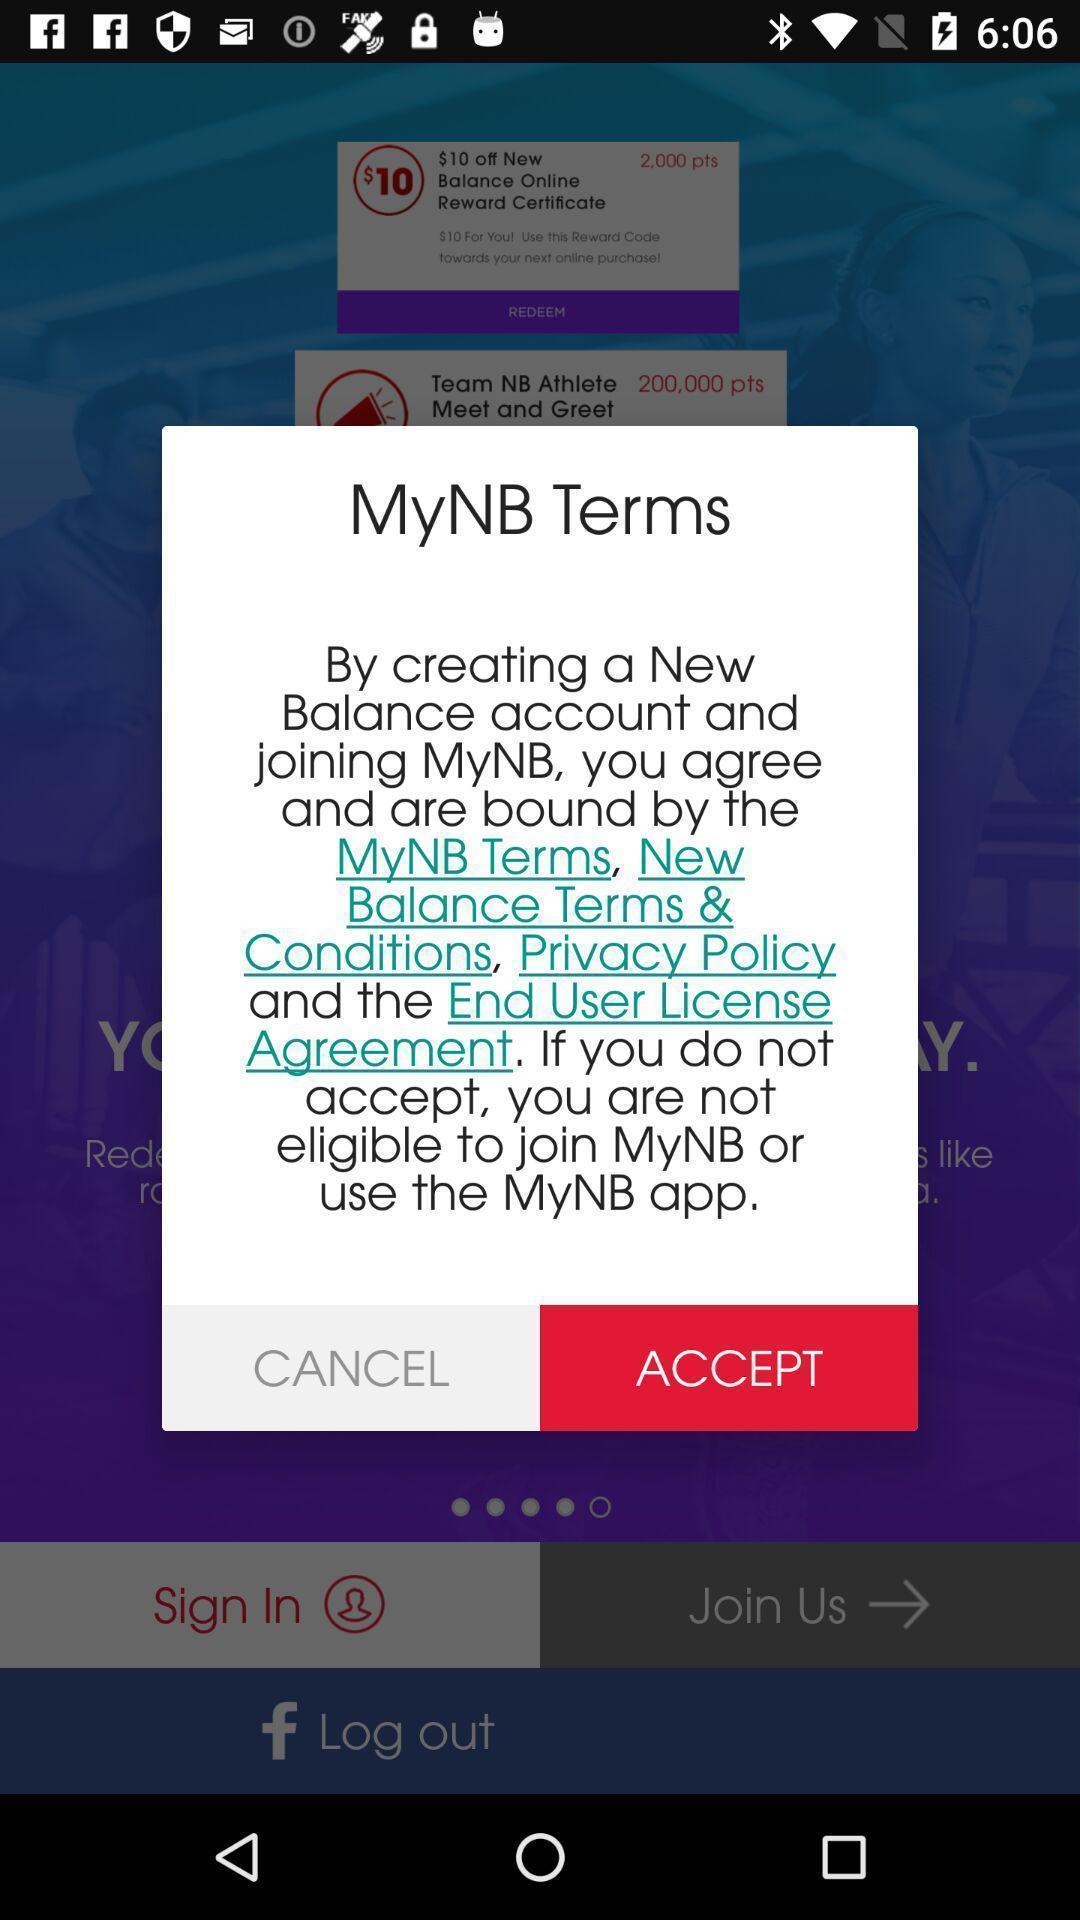What details can you identify in this image? Pop-up window asking to accept the agreement. 